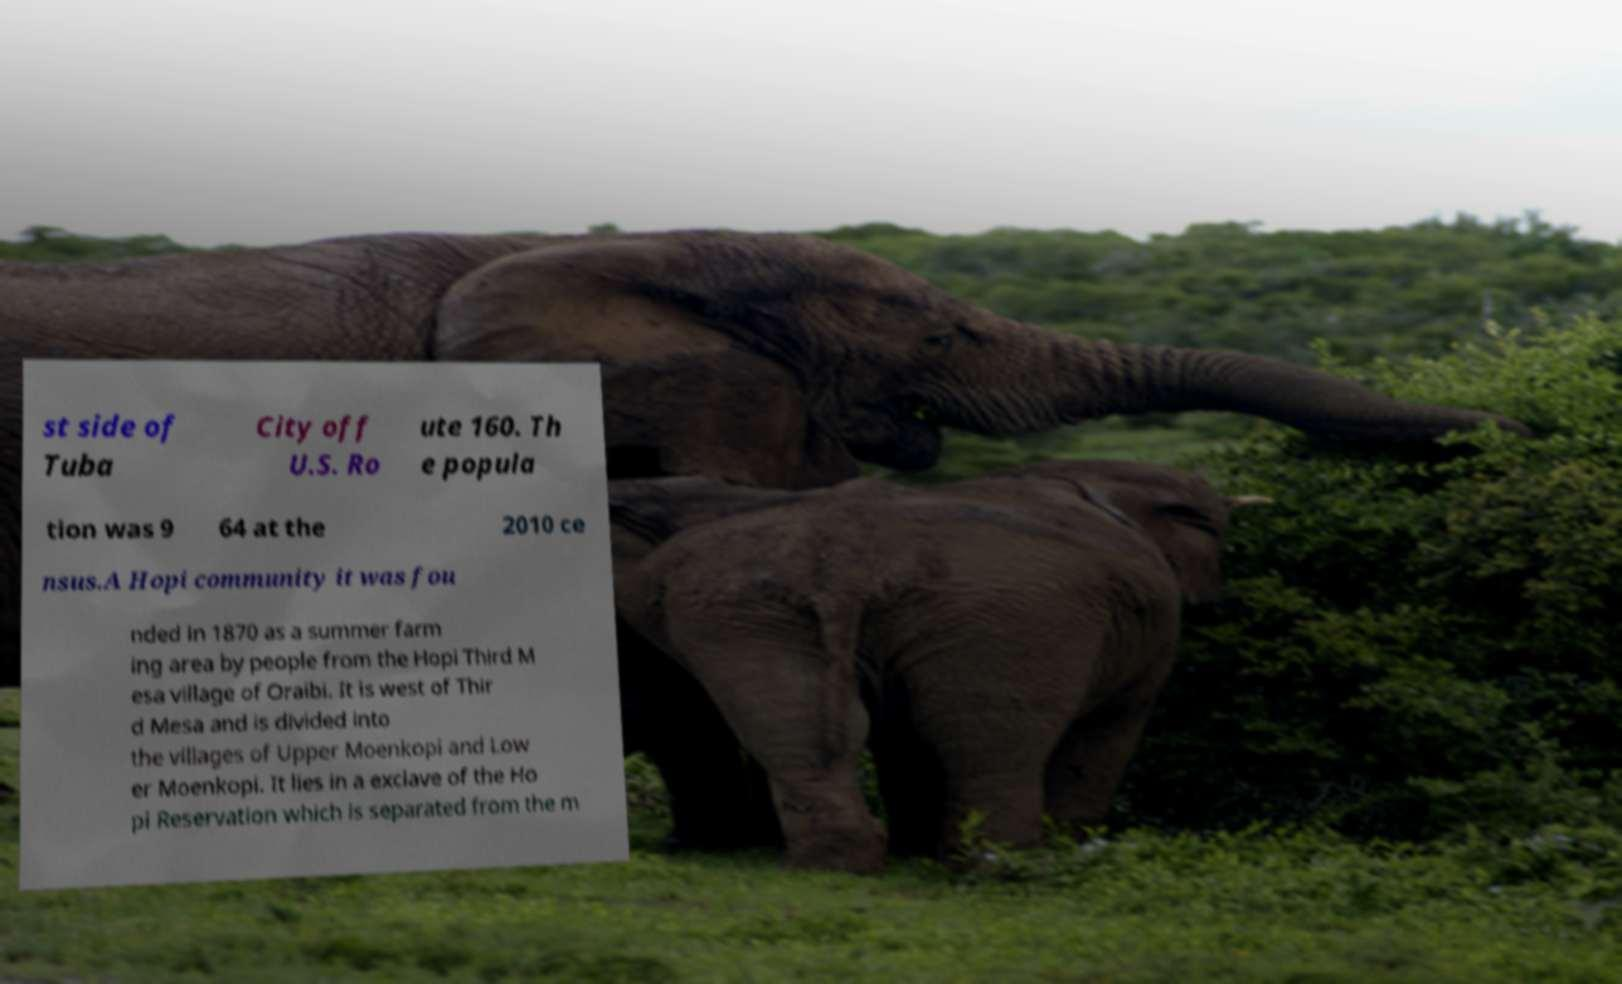Could you extract and type out the text from this image? st side of Tuba City off U.S. Ro ute 160. Th e popula tion was 9 64 at the 2010 ce nsus.A Hopi community it was fou nded in 1870 as a summer farm ing area by people from the Hopi Third M esa village of Oraibi. It is west of Thir d Mesa and is divided into the villages of Upper Moenkopi and Low er Moenkopi. It lies in a exclave of the Ho pi Reservation which is separated from the m 